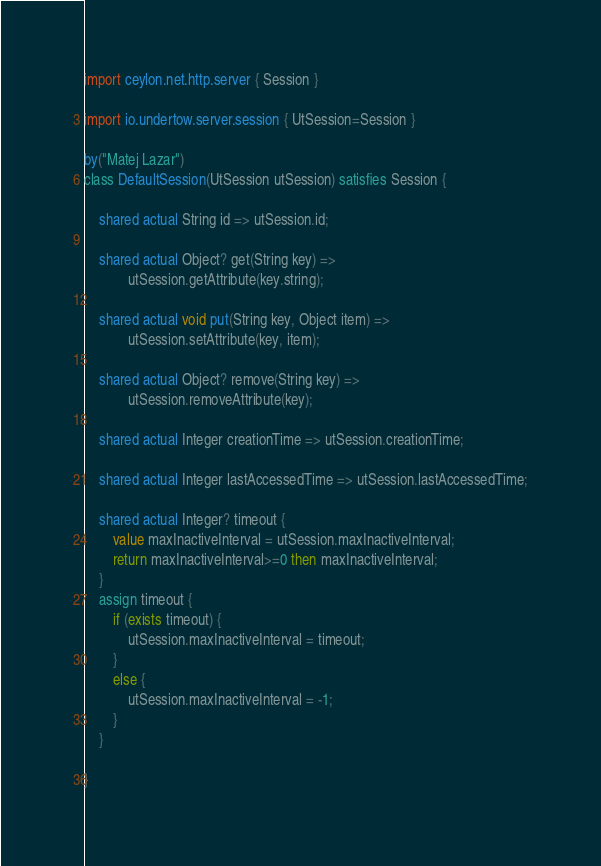<code> <loc_0><loc_0><loc_500><loc_500><_Ceylon_>import ceylon.net.http.server { Session }

import io.undertow.server.session { UtSession=Session }

by("Matej Lazar")
class DefaultSession(UtSession utSession) satisfies Session {
    
    shared actual String id => utSession.id;
    
    shared actual Object? get(String key) => 
            utSession.getAttribute(key.string);
    
    shared actual void put(String key, Object item) =>
            utSession.setAttribute(key, item);
    
    shared actual Object? remove(String key) =>
            utSession.removeAttribute(key);
    
    shared actual Integer creationTime => utSession.creationTime;
    
    shared actual Integer lastAccessedTime => utSession.lastAccessedTime;
    
    shared actual Integer? timeout {
        value maxInactiveInterval = utSession.maxInactiveInterval;
        return maxInactiveInterval>=0 then maxInactiveInterval;
    }
    assign timeout {
        if (exists timeout) {
            utSession.maxInactiveInterval = timeout;
        }
        else {
            utSession.maxInactiveInterval = -1;
        }
    }
    
}
</code> 